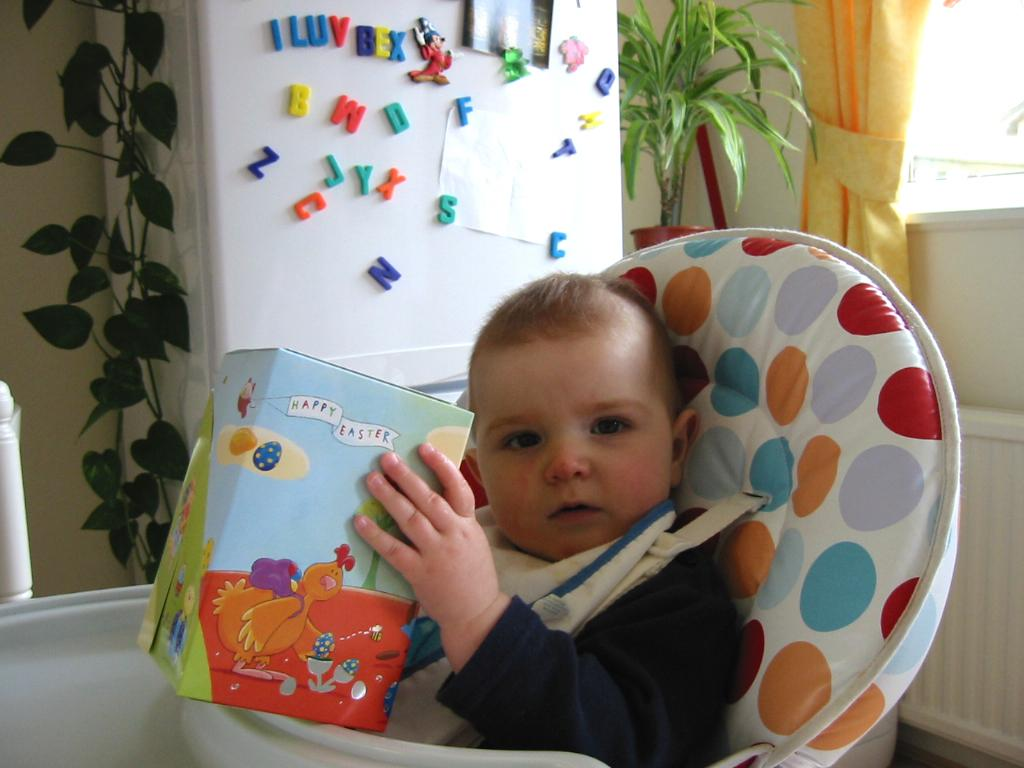What is the main subject of the image? There is a baby boy in the image. What is the baby boy doing in the image? The baby boy is sitting on a chair and holding a book. What can be seen in the background of the image? There are trees visible in the background of the image. What type of gold jewelry is the baby boy wearing in the image? There is no gold jewelry visible on the baby boy in the image. Can you tell me how the judge is interacting with the baby boy in the image? There is no judge present in the image; it only features a baby boy sitting on a chair and holding a book. 